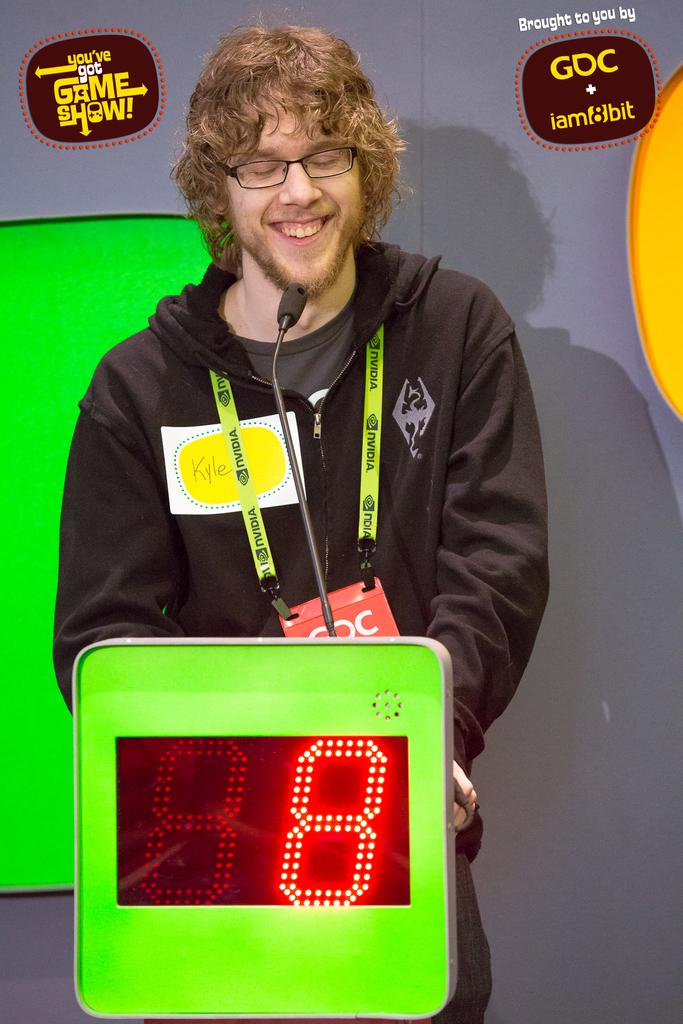What is the man in the image doing? The man is standing in the image and smiling. What type of clothing is the man wearing? The man is wearing a jerkin, a T-shirt, a badge, spectacles, and trousers. What can be seen in the background of the image? There is a small digital scoreboard in the image. Are there any marks on the image itself? Yes, there are watermarks on the image. What is the government's stance on the man's feelings in the image? The image does not provide any information about the man's feelings or the government's stance on them. What type of room is the man standing in? The image does not provide any information about the room or its type. 